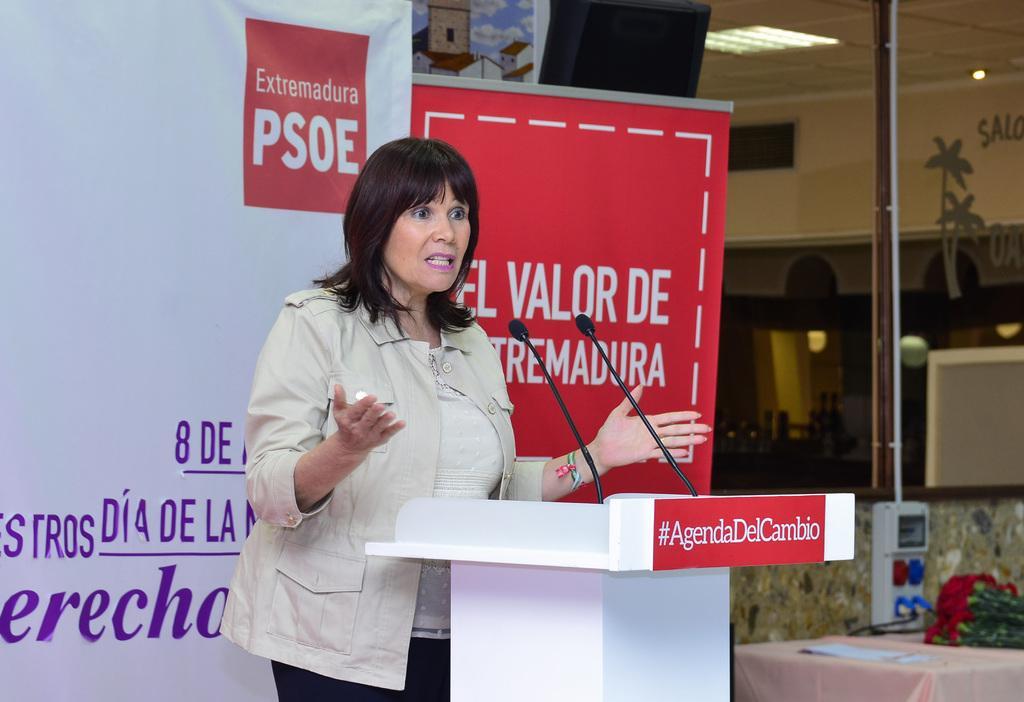Can you describe this image briefly? In the center of the image there is a lady. There is a mic placed before her. In the background there is a board. There is a table. There is a bouquet placed on the table. There is a podium. 